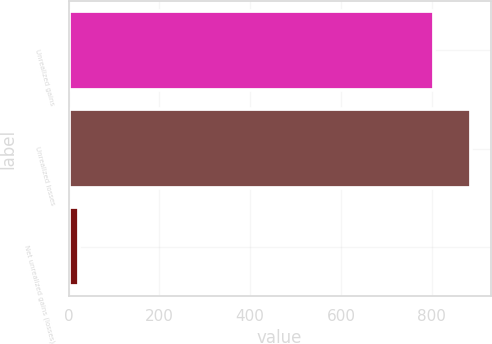Convert chart to OTSL. <chart><loc_0><loc_0><loc_500><loc_500><bar_chart><fcel>Unrealized gains<fcel>Unrealized losses<fcel>Net unrealized gains (losses)<nl><fcel>805<fcel>885.5<fcel>23<nl></chart> 